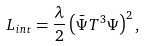<formula> <loc_0><loc_0><loc_500><loc_500>L _ { i n t } = \frac { \lambda } { 2 } \left ( \bar { \Psi } T ^ { 3 } \Psi \right ) ^ { 2 } ,</formula> 